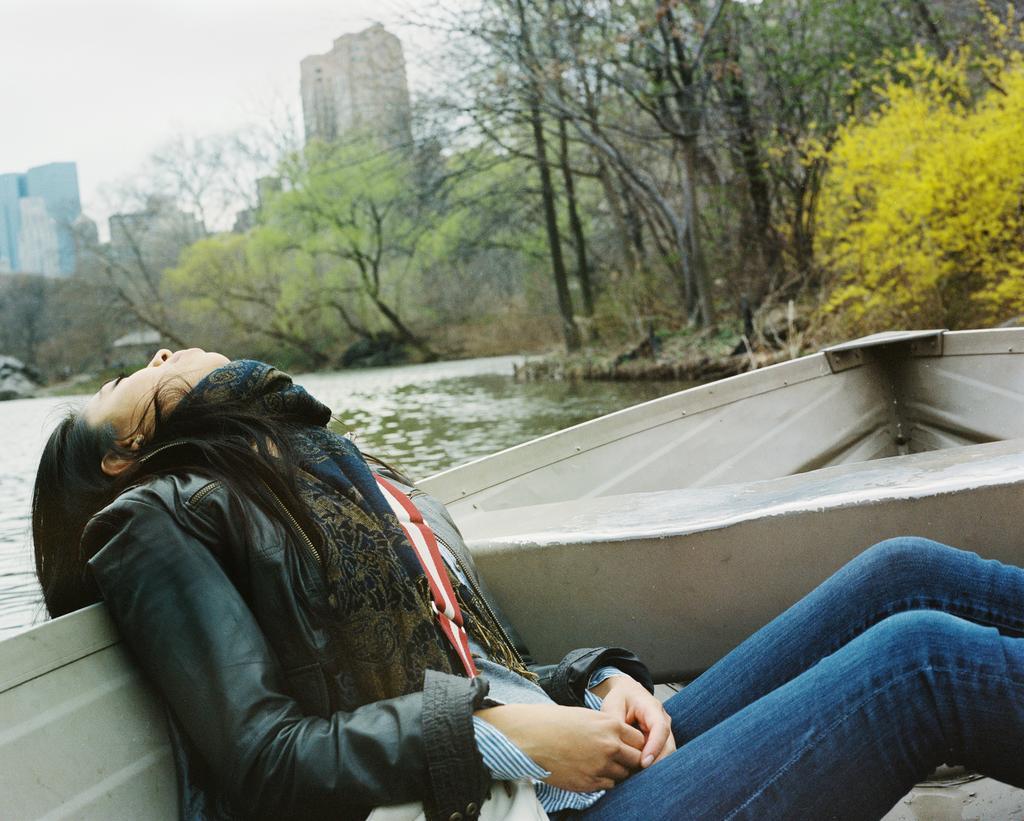How would you summarize this image in a sentence or two? In this image I can see a woman who is sitting on a boat. In the middle of this picture I can see the water and number of trees. In the background I can see the buildings and the sky. 